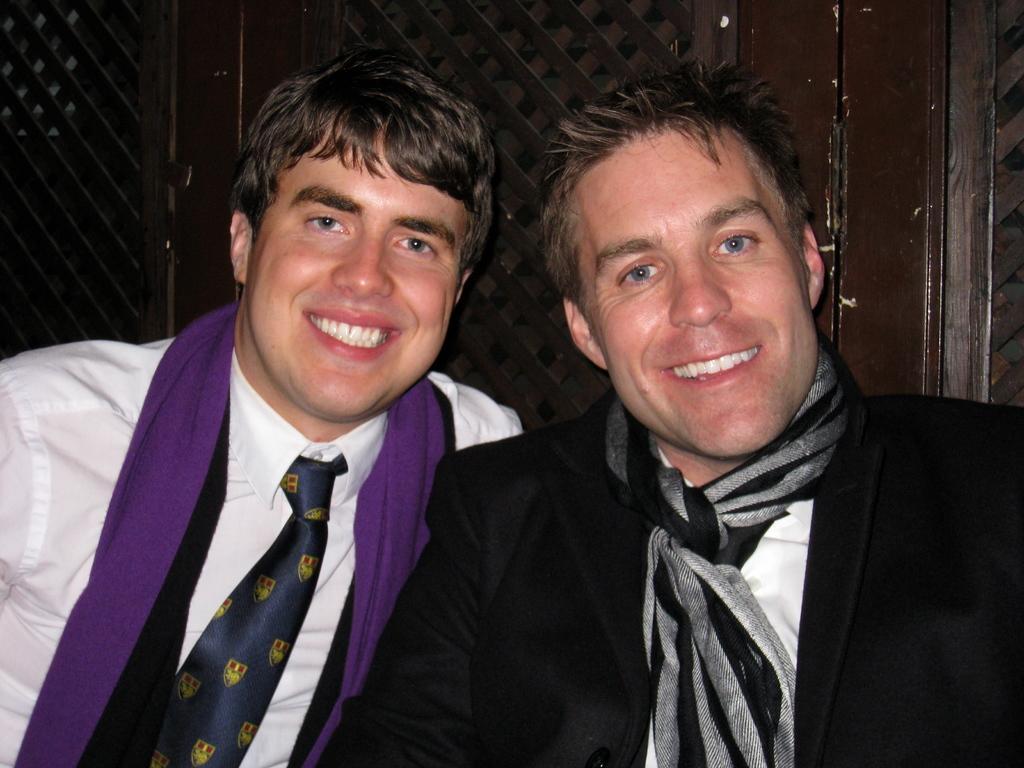How would you summarize this image in a sentence or two? In the image in the center, we can see two people are smiling, which we can see on their faces. In the background there is a wooden wall. 